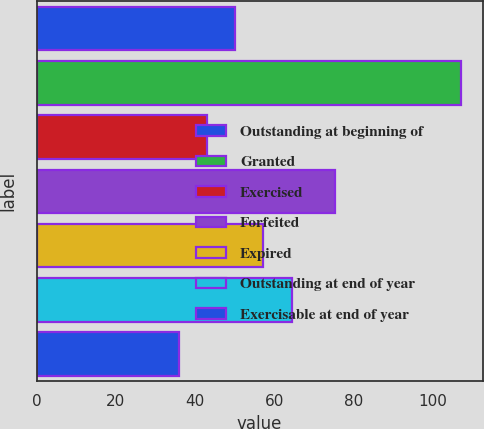<chart> <loc_0><loc_0><loc_500><loc_500><bar_chart><fcel>Outstanding at beginning of<fcel>Granted<fcel>Exercised<fcel>Forfeited<fcel>Expired<fcel>Outstanding at end of year<fcel>Exercisable at end of year<nl><fcel>50.18<fcel>107.31<fcel>43.04<fcel>75.26<fcel>57.32<fcel>64.46<fcel>35.9<nl></chart> 